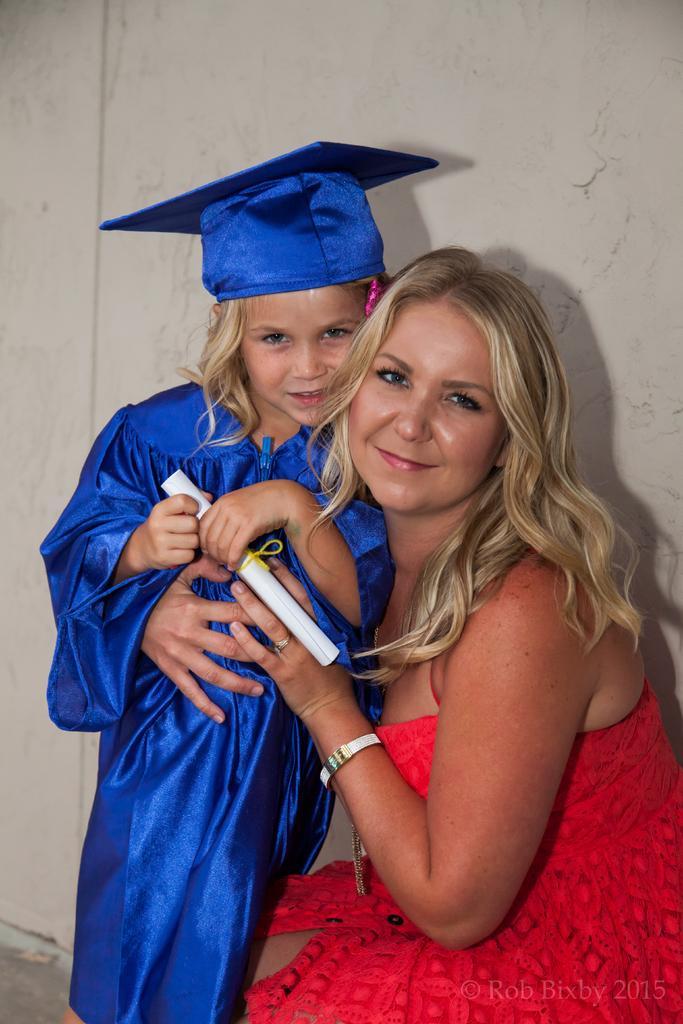Can you describe this image briefly? In this image I can see a woman wearing red colored dress and a child wearing blue colored dress. Child is holding a paper in hands. I can see the wall in the background. 